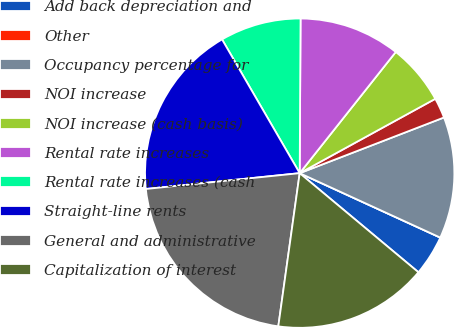Convert chart to OTSL. <chart><loc_0><loc_0><loc_500><loc_500><pie_chart><fcel>Add back depreciation and<fcel>Other<fcel>Occupancy percentage for<fcel>NOI increase<fcel>NOI increase (cash basis)<fcel>Rental rate increases<fcel>Rental rate increases (cash<fcel>Straight-line rents<fcel>General and administrative<fcel>Capitalization of interest<nl><fcel>4.23%<fcel>0.0%<fcel>12.7%<fcel>2.12%<fcel>6.35%<fcel>10.58%<fcel>8.46%<fcel>18.26%<fcel>21.16%<fcel>16.14%<nl></chart> 